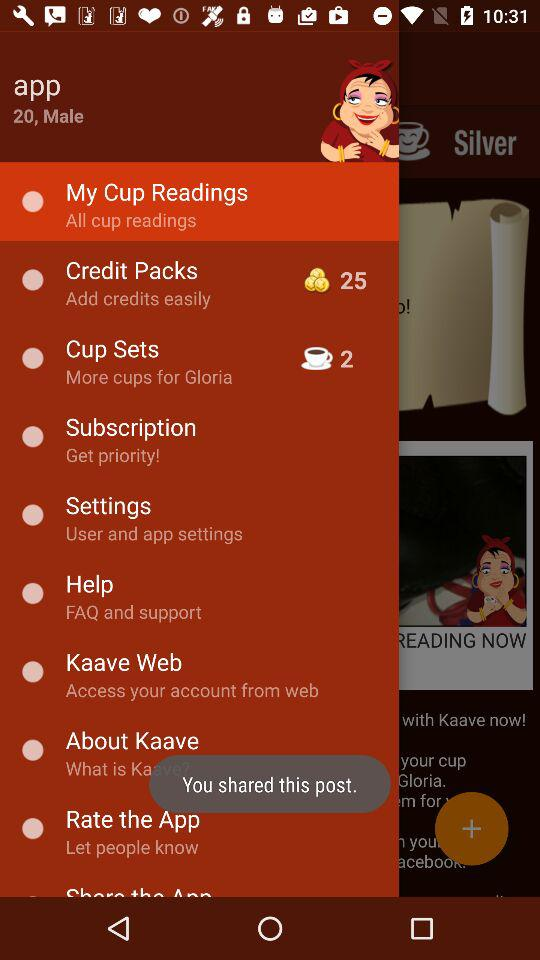How many credits are there? There are 25 credits. 